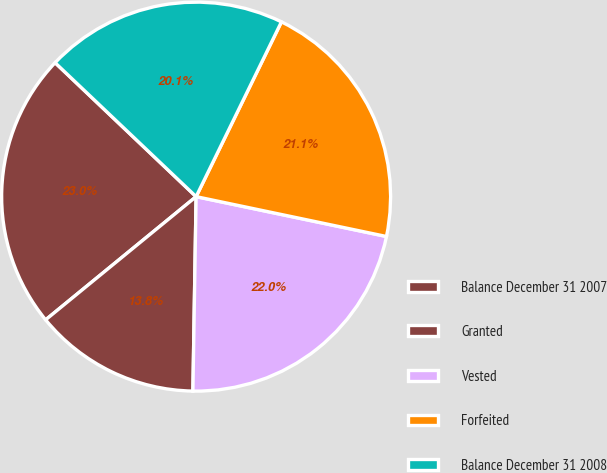Convert chart. <chart><loc_0><loc_0><loc_500><loc_500><pie_chart><fcel>Balance December 31 2007<fcel>Granted<fcel>Vested<fcel>Forfeited<fcel>Balance December 31 2008<nl><fcel>23.01%<fcel>13.82%<fcel>21.98%<fcel>21.06%<fcel>20.14%<nl></chart> 